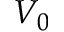Convert formula to latex. <formula><loc_0><loc_0><loc_500><loc_500>V _ { 0 }</formula> 